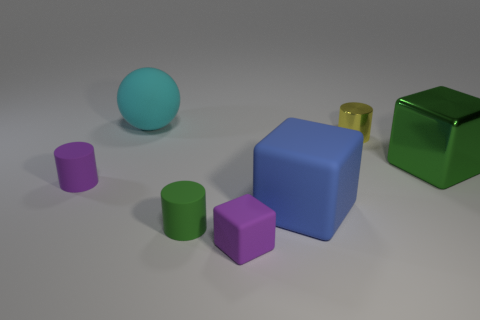The tiny cylinder that is both to the right of the rubber ball and in front of the big green object is what color?
Offer a very short reply. Green. There is a tiny rubber cylinder behind the blue object; does it have the same color as the tiny block?
Keep it short and to the point. Yes. What is the shape of the blue matte thing that is the same size as the cyan matte sphere?
Keep it short and to the point. Cube. How many other things are there of the same color as the sphere?
Your response must be concise. 0. How many other objects are the same material as the large blue cube?
Provide a short and direct response. 4. Does the blue matte cube have the same size as the green thing to the right of the tiny green rubber cylinder?
Give a very brief answer. Yes. What is the color of the small metallic cylinder?
Your response must be concise. Yellow. There is a green thing to the left of the small cylinder behind the metal object in front of the yellow metal thing; what is its shape?
Your answer should be compact. Cylinder. What is the purple object to the left of the cube in front of the green cylinder made of?
Your answer should be very brief. Rubber. There is a large object that is the same material as the large cyan ball; what shape is it?
Make the answer very short. Cube. 